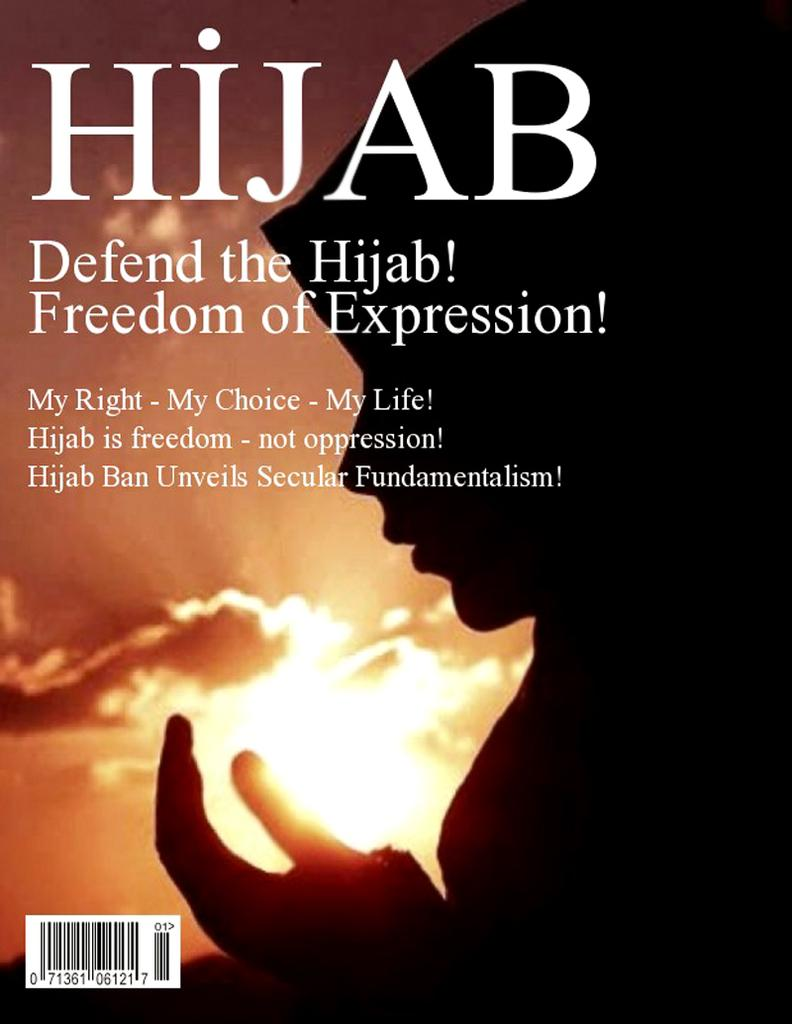<image>
Render a clear and concise summary of the photo. The cover of a book describing the Hijab as a freedom of expression. 